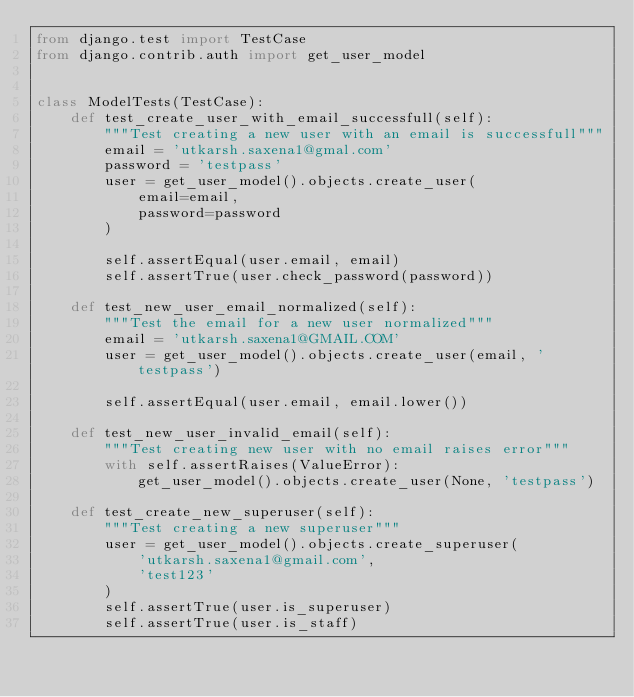Convert code to text. <code><loc_0><loc_0><loc_500><loc_500><_Python_>from django.test import TestCase
from django.contrib.auth import get_user_model


class ModelTests(TestCase):
    def test_create_user_with_email_successfull(self):
        """Test creating a new user with an email is successfull"""
        email = 'utkarsh.saxena1@gmal.com'
        password = 'testpass'
        user = get_user_model().objects.create_user(
            email=email,
            password=password
        )

        self.assertEqual(user.email, email)
        self.assertTrue(user.check_password(password))

    def test_new_user_email_normalized(self):
        """Test the email for a new user normalized"""
        email = 'utkarsh.saxena1@GMAIL.COM'
        user = get_user_model().objects.create_user(email, 'testpass')

        self.assertEqual(user.email, email.lower())

    def test_new_user_invalid_email(self):
        """Test creating new user with no email raises error"""
        with self.assertRaises(ValueError):
            get_user_model().objects.create_user(None, 'testpass')

    def test_create_new_superuser(self):
        """Test creating a new superuser"""
        user = get_user_model().objects.create_superuser(
            'utkarsh.saxena1@gmail.com',
            'test123'
        )
        self.assertTrue(user.is_superuser)
        self.assertTrue(user.is_staff)</code> 